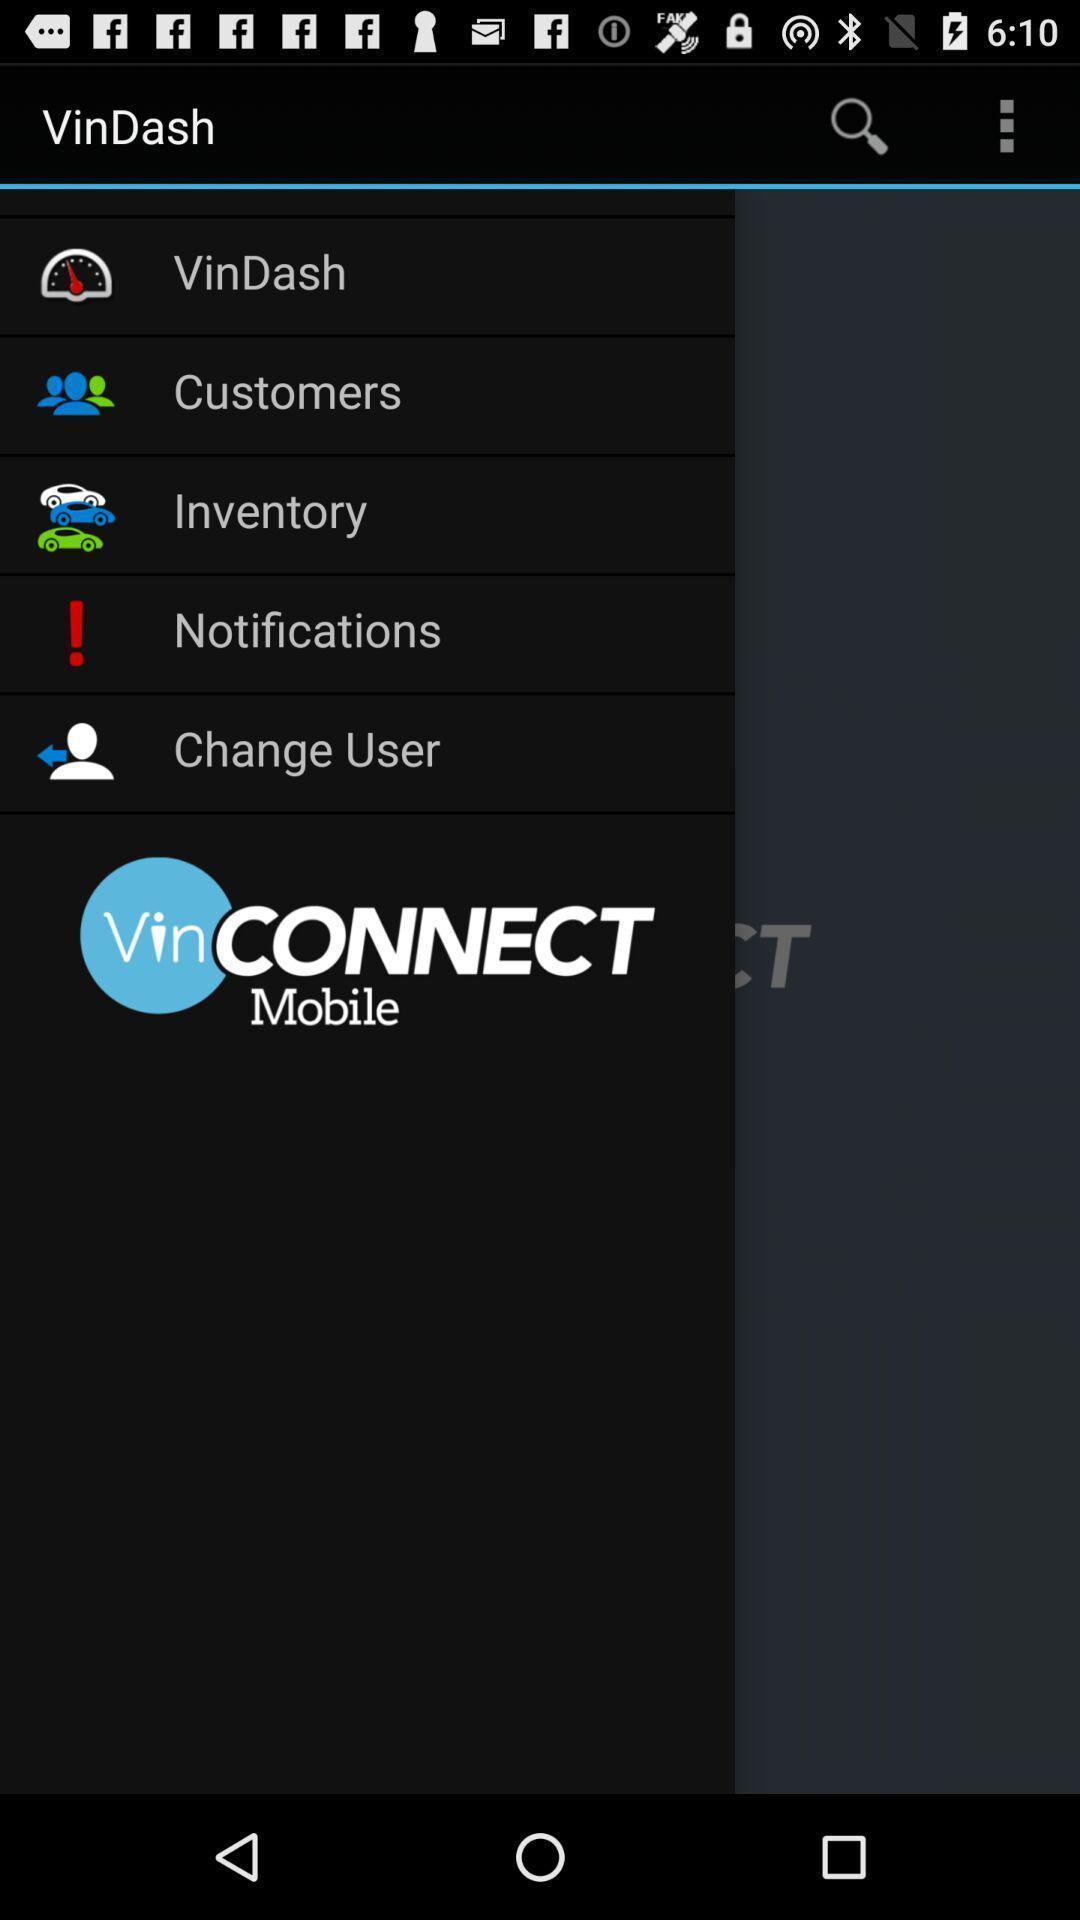Provide a detailed account of this screenshot. Screen displaying multiple options in an e-hailing application. 